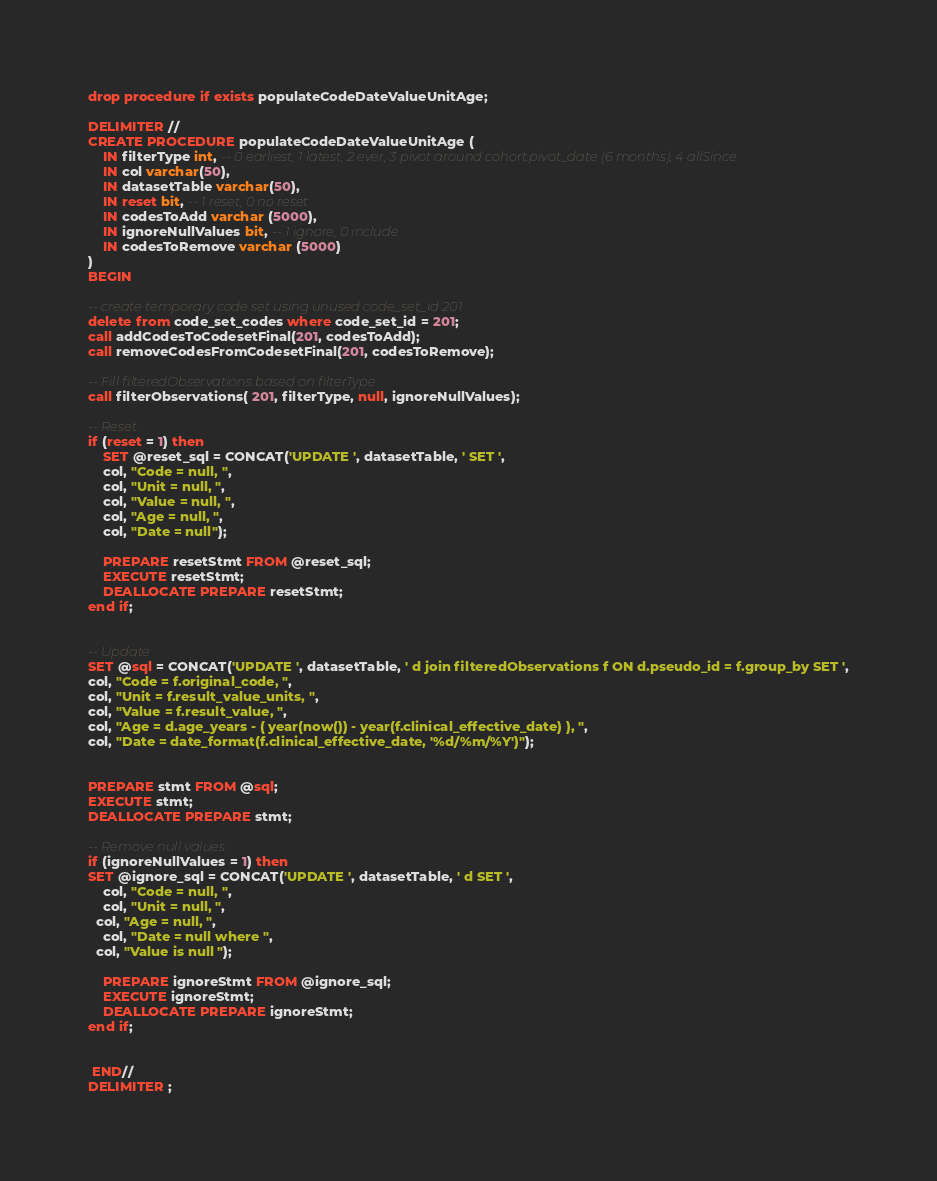Convert code to text. <code><loc_0><loc_0><loc_500><loc_500><_SQL_>drop procedure if exists populateCodeDateValueUnitAge;

DELIMITER //
CREATE PROCEDURE populateCodeDateValueUnitAge (
    IN filterType int, -- 0 earliest, 1 latest, 2 ever, 3 pivot around cohort.pivot_date (6 months), 4 allSince
    IN col varchar(50),
    IN datasetTable varchar(50),
    IN reset bit, -- 1 reset, 0 no reset
    IN codesToAdd varchar (5000),
    IN ignoreNullValues bit, -- 1 ignore, 0 include
    IN codesToRemove varchar (5000)
)
BEGIN

-- create temporary code set using unused code_set_id 201
delete from code_set_codes where code_set_id = 201;
call addCodesToCodesetFinal(201, codesToAdd);
call removeCodesFromCodesetFinal(201, codesToRemove);

-- Fill filteredObservations based on filterType
call filterObservations( 201, filterType, null, ignoreNullValues);

-- Reset
if (reset = 1) then
	SET @reset_sql = CONCAT('UPDATE ', datasetTable, ' SET ',
	col, "Code = null, ",
	col, "Unit = null, ",
	col, "Value = null, ",
	col, "Age = null, ",
	col, "Date = null");

	PREPARE resetStmt FROM @reset_sql;
	EXECUTE resetStmt;
	DEALLOCATE PREPARE resetStmt;
end if;


-- Update
SET @sql = CONCAT('UPDATE ', datasetTable, ' d join filteredObservations f ON d.pseudo_id = f.group_by SET ',
col, "Code = f.original_code, ",
col, "Unit = f.result_value_units, ",
col, "Value = f.result_value, ",
col, "Age = d.age_years - ( year(now()) - year(f.clinical_effective_date) ), ",
col, "Date = date_format(f.clinical_effective_date, '%d/%m/%Y')");


PREPARE stmt FROM @sql;
EXECUTE stmt;
DEALLOCATE PREPARE stmt;

-- Remove null values
if (ignoreNullValues = 1) then
SET @ignore_sql = CONCAT('UPDATE ', datasetTable, ' d SET ',
	col, "Code = null, ",
	col, "Unit = null, ",
  col, "Age = null, ",
	col, "Date = null where ",
  col, "Value is null ");

	PREPARE ignoreStmt FROM @ignore_sql;
	EXECUTE ignoreStmt;
	DEALLOCATE PREPARE ignoreStmt;
end if;


 END//
DELIMITER ;
</code> 